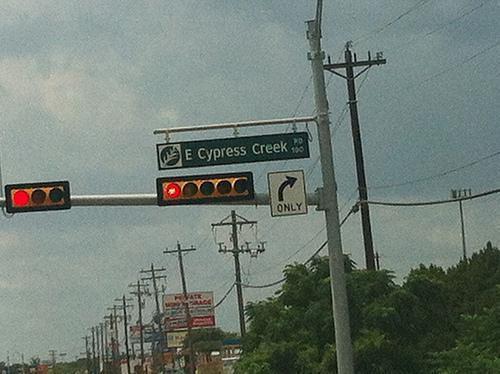How many traffic lights are in the picture?
Give a very brief answer. 8. 